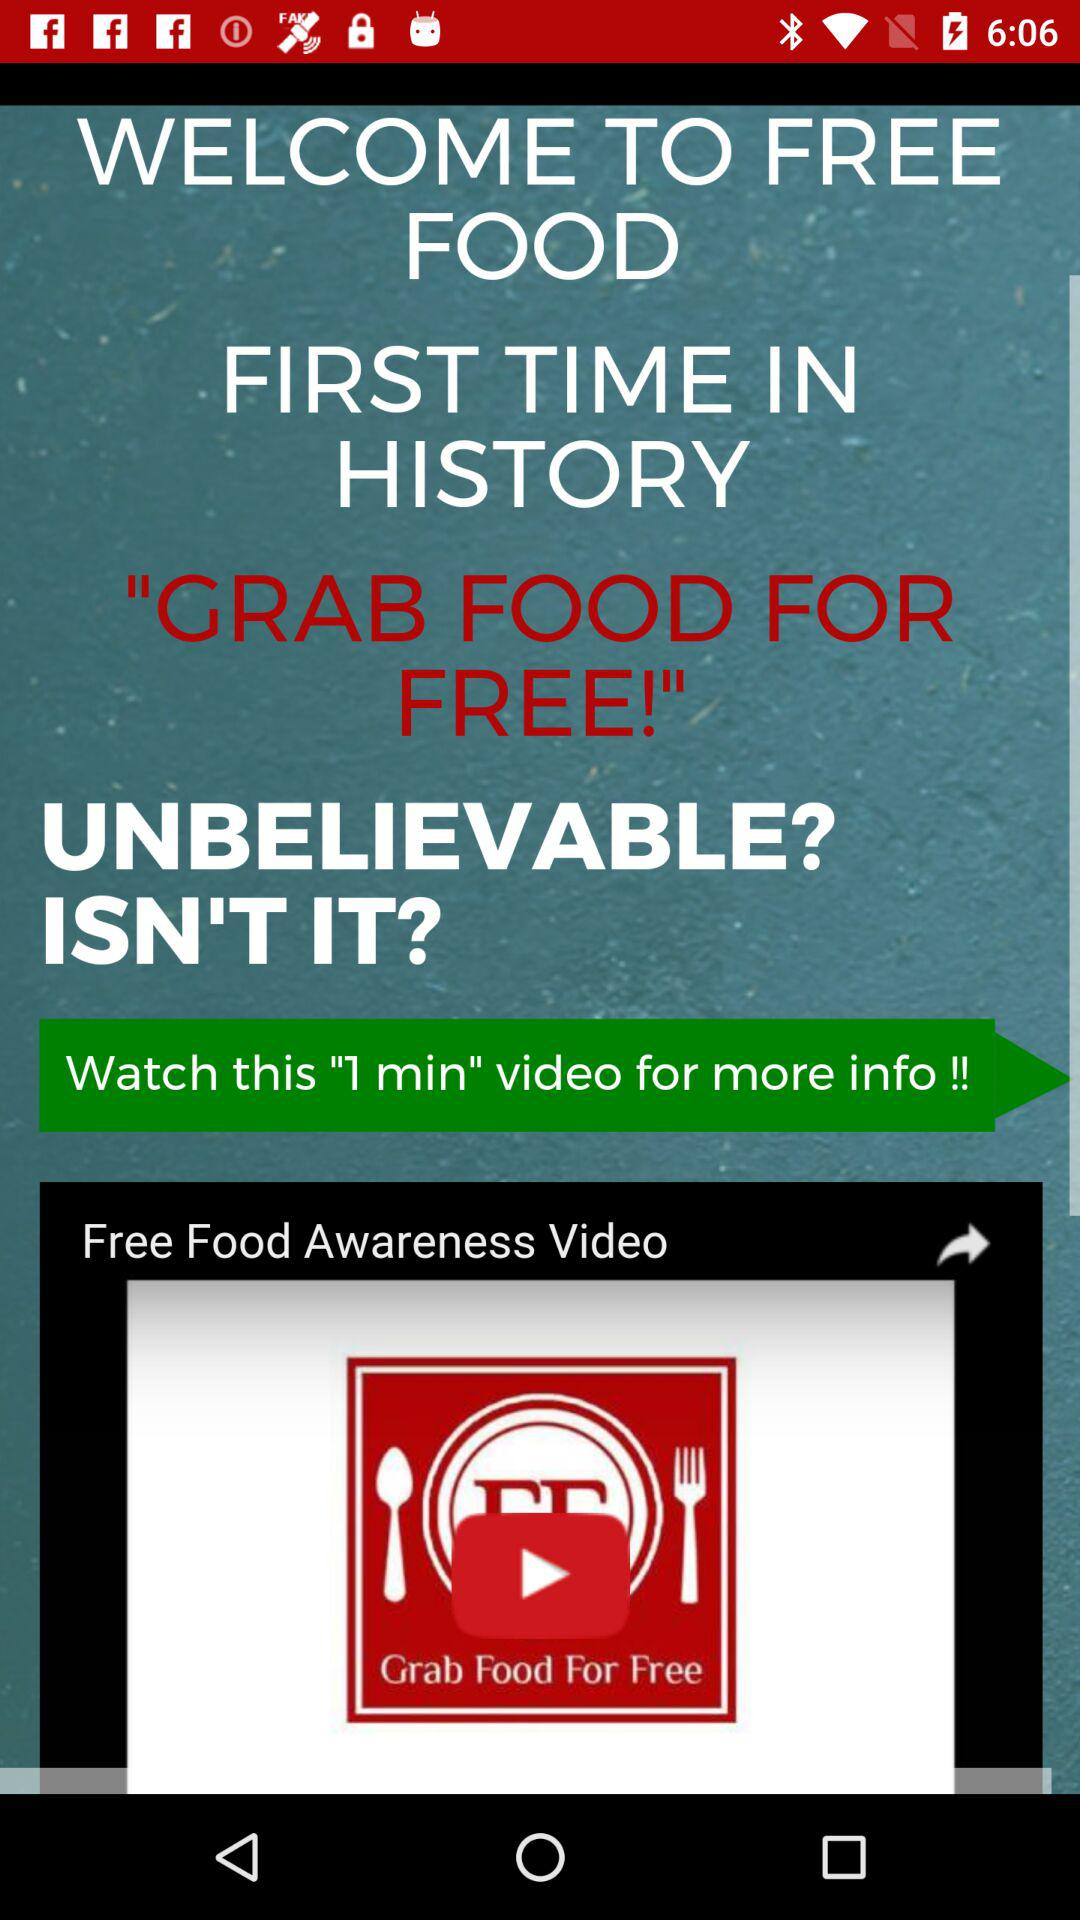What is the title of the video? The title of the video is "GRAB FOOD FOR FREE!". 